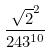<formula> <loc_0><loc_0><loc_500><loc_500>\frac { \sqrt { 2 } ^ { 2 } } { 2 4 3 ^ { 1 0 } }</formula> 